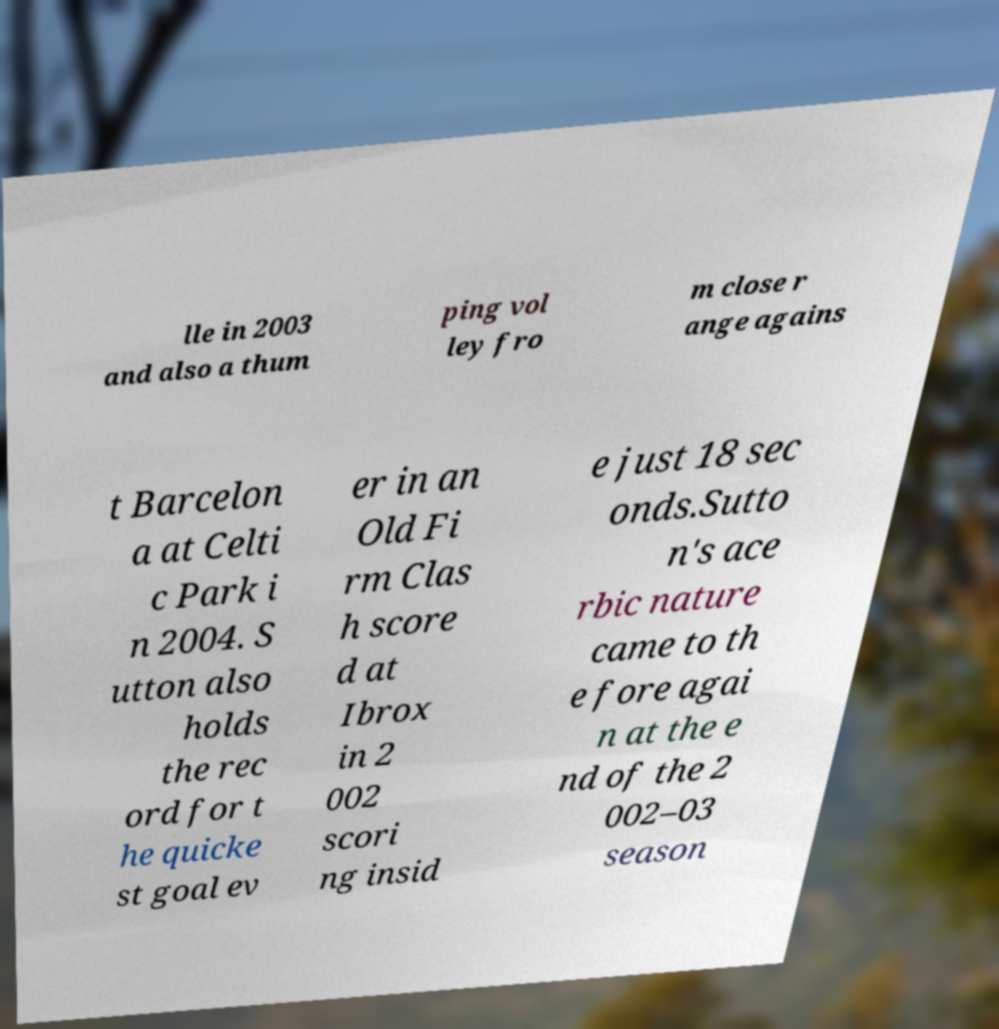For documentation purposes, I need the text within this image transcribed. Could you provide that? lle in 2003 and also a thum ping vol ley fro m close r ange agains t Barcelon a at Celti c Park i n 2004. S utton also holds the rec ord for t he quicke st goal ev er in an Old Fi rm Clas h score d at Ibrox in 2 002 scori ng insid e just 18 sec onds.Sutto n's ace rbic nature came to th e fore agai n at the e nd of the 2 002–03 season 